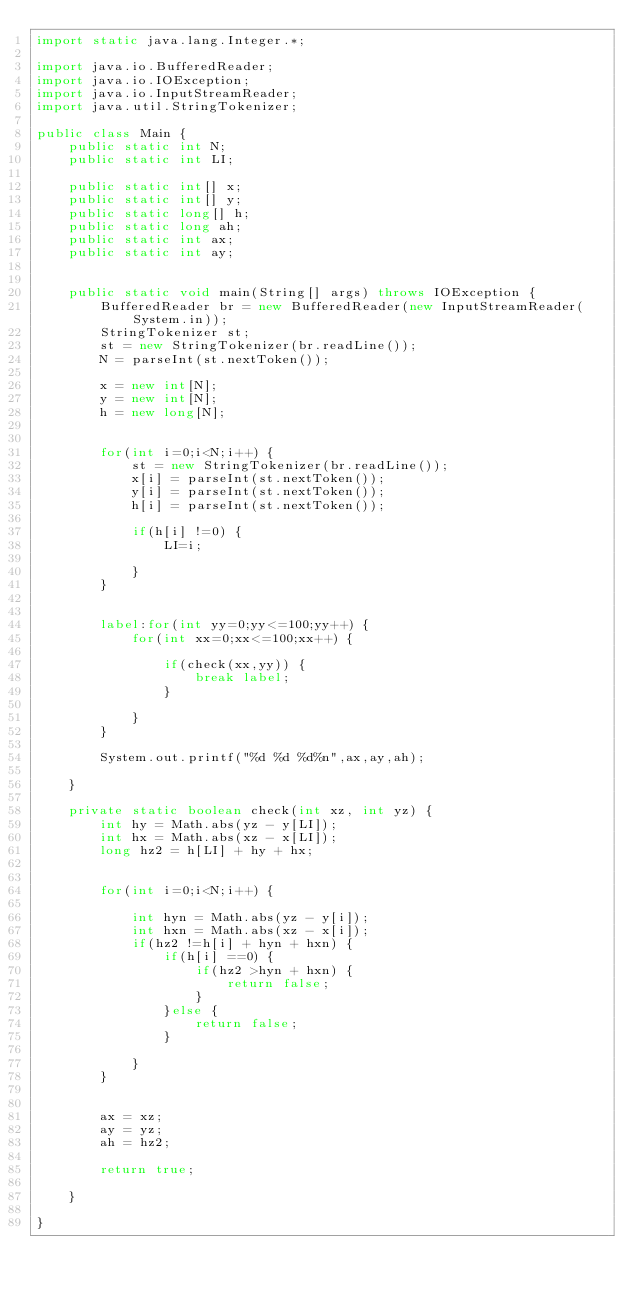<code> <loc_0><loc_0><loc_500><loc_500><_Java_>import static java.lang.Integer.*;

import java.io.BufferedReader;
import java.io.IOException;
import java.io.InputStreamReader;
import java.util.StringTokenizer;

public class Main {
	public static int N;
	public static int LI;

	public static int[] x;
	public static int[] y;
	public static long[] h;
	public static long ah;
	public static int ax;
	public static int ay;


	public static void main(String[] args) throws IOException {
		BufferedReader br = new BufferedReader(new InputStreamReader(System.in));
        StringTokenizer st;
		st = new StringTokenizer(br.readLine());
		N = parseInt(st.nextToken());

		x = new int[N];
		y = new int[N];
		h = new long[N];


		for(int i=0;i<N;i++) {
			st = new StringTokenizer(br.readLine());
			x[i] = parseInt(st.nextToken());
			y[i] = parseInt(st.nextToken());
			h[i] = parseInt(st.nextToken());

			if(h[i] !=0) {
				LI=i;

			}
		}


		label:for(int yy=0;yy<=100;yy++) {
			for(int xx=0;xx<=100;xx++) {

				if(check(xx,yy)) {
					break label;
				}

			}
		}

		System.out.printf("%d %d %d%n",ax,ay,ah);

	}

	private static boolean check(int xz, int yz) {
		int hy = Math.abs(yz - y[LI]);
		int hx = Math.abs(xz - x[LI]);
		long hz2 = h[LI] + hy + hx;


		for(int i=0;i<N;i++) {

			int hyn = Math.abs(yz - y[i]);
			int hxn = Math.abs(xz - x[i]);
			if(hz2 !=h[i] + hyn + hxn) {
				if(h[i] ==0) {
					if(hz2 >hyn + hxn) {
						return false;
					}
				}else {
					return false;
				}

			}
		}


		ax = xz;
		ay = yz;
		ah = hz2;

		return true;

	}

}</code> 